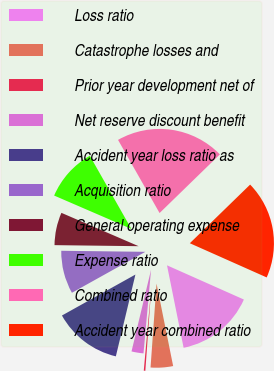<chart> <loc_0><loc_0><loc_500><loc_500><pie_chart><fcel>Loss ratio<fcel>Catastrophe losses and<fcel>Prior year development net of<fcel>Net reserve discount benefit<fcel>Accident year loss ratio as<fcel>Acquisition ratio<fcel>General operating expense<fcel>Expense ratio<fcel>Combined ratio<fcel>Accident year combined ratio<nl><fcel>15.17%<fcel>4.3%<fcel>0.3%<fcel>2.3%<fcel>13.17%<fcel>8.29%<fcel>6.29%<fcel>10.29%<fcel>20.94%<fcel>18.94%<nl></chart> 